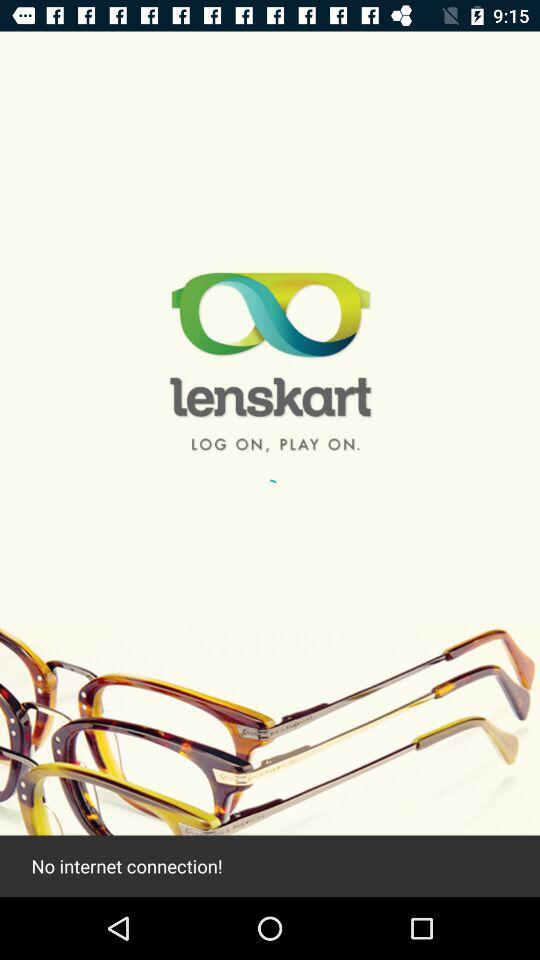What is the application name? The application name is "lenskart". 